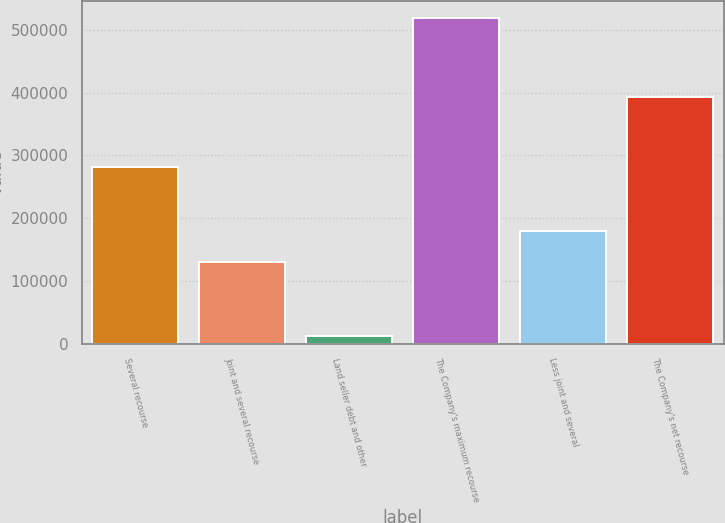Convert chart to OTSL. <chart><loc_0><loc_0><loc_500><loc_500><bar_chart><fcel>Several recourse<fcel>Joint and several recourse<fcel>Land seller debt and other<fcel>The Company's maximum recourse<fcel>Less joint and several<fcel>The Company's net recourse<nl><fcel>281630<fcel>129318<fcel>12170<fcel>519878<fcel>180089<fcel>392450<nl></chart> 